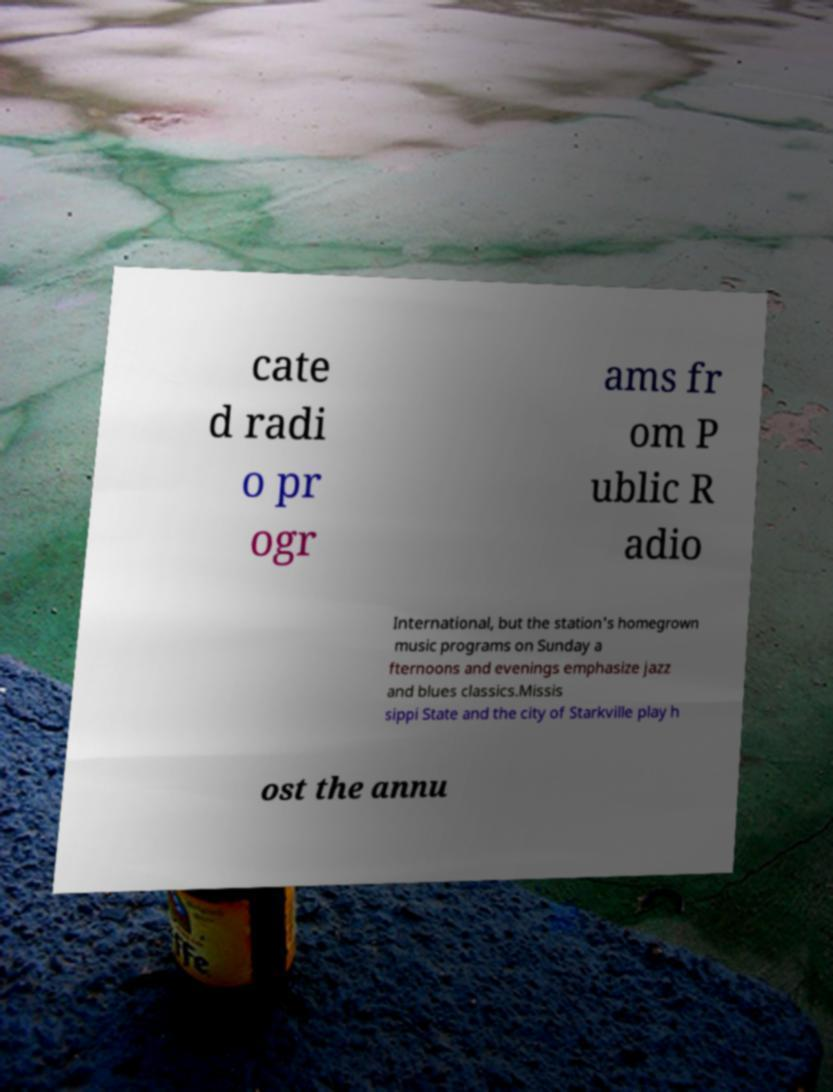Could you assist in decoding the text presented in this image and type it out clearly? cate d radi o pr ogr ams fr om P ublic R adio International, but the station's homegrown music programs on Sunday a fternoons and evenings emphasize jazz and blues classics.Missis sippi State and the city of Starkville play h ost the annu 